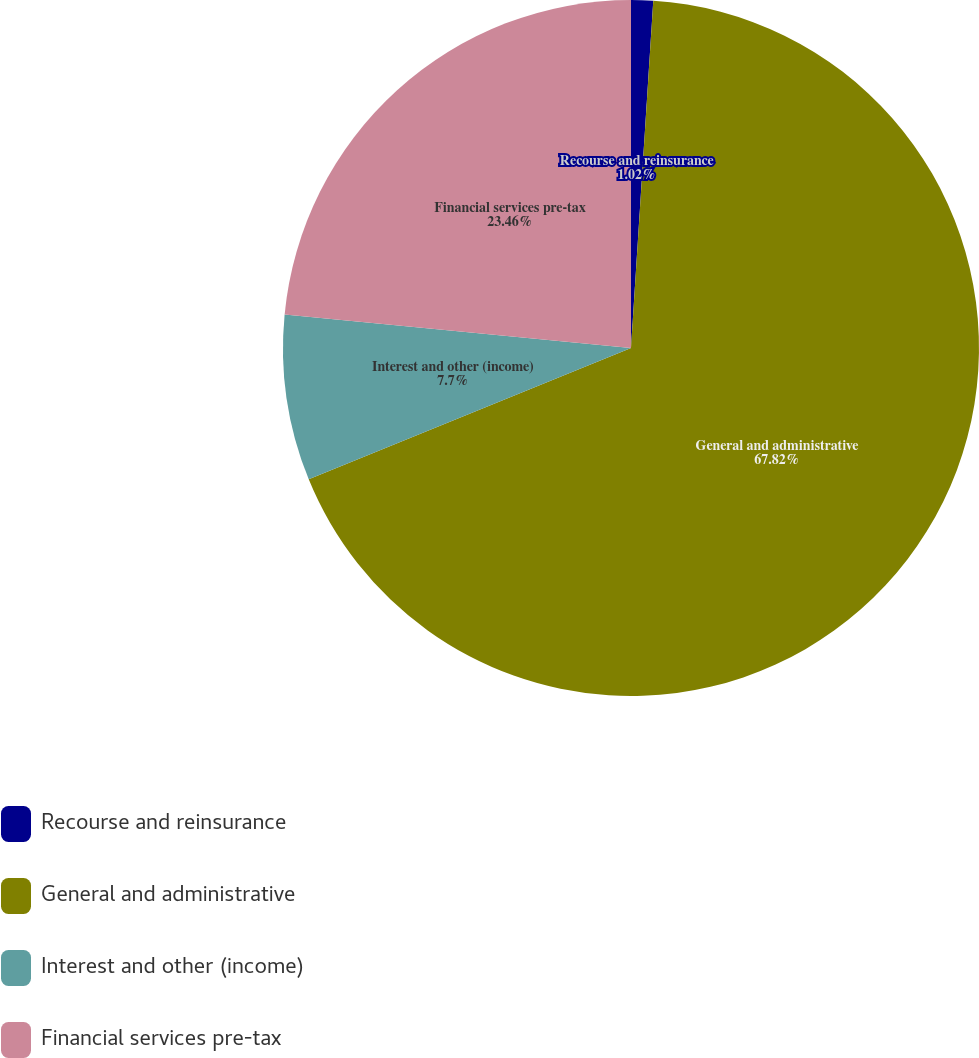Convert chart to OTSL. <chart><loc_0><loc_0><loc_500><loc_500><pie_chart><fcel>Recourse and reinsurance<fcel>General and administrative<fcel>Interest and other (income)<fcel>Financial services pre-tax<nl><fcel>1.02%<fcel>67.82%<fcel>7.7%<fcel>23.46%<nl></chart> 